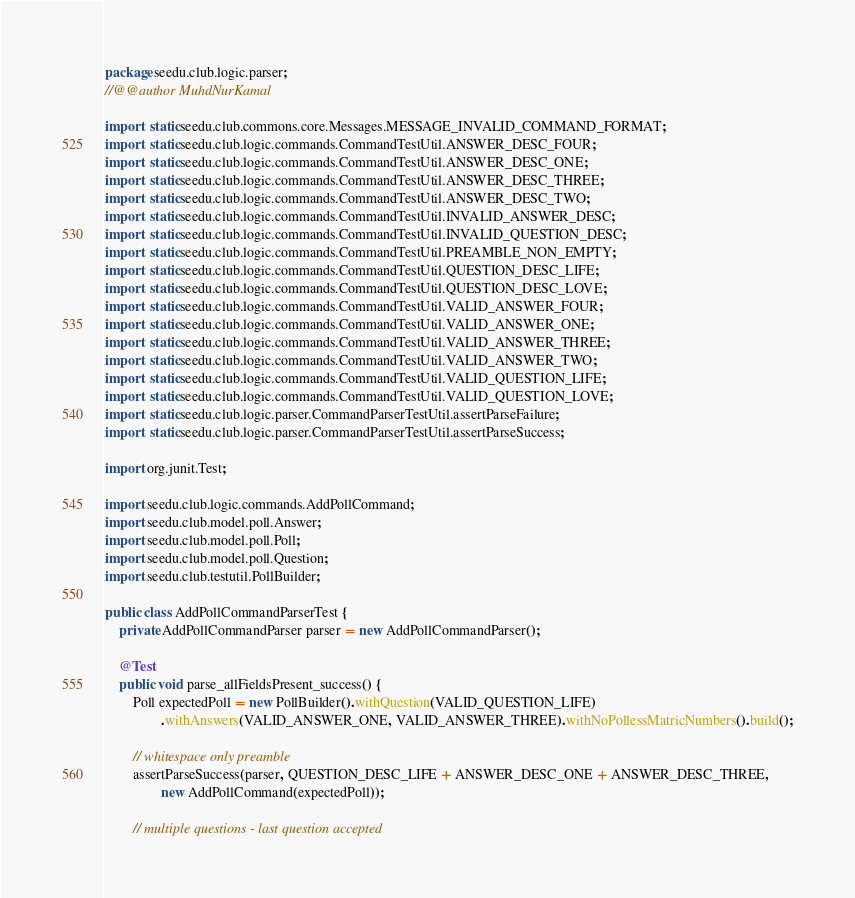Convert code to text. <code><loc_0><loc_0><loc_500><loc_500><_Java_>package seedu.club.logic.parser;
//@@author MuhdNurKamal

import static seedu.club.commons.core.Messages.MESSAGE_INVALID_COMMAND_FORMAT;
import static seedu.club.logic.commands.CommandTestUtil.ANSWER_DESC_FOUR;
import static seedu.club.logic.commands.CommandTestUtil.ANSWER_DESC_ONE;
import static seedu.club.logic.commands.CommandTestUtil.ANSWER_DESC_THREE;
import static seedu.club.logic.commands.CommandTestUtil.ANSWER_DESC_TWO;
import static seedu.club.logic.commands.CommandTestUtil.INVALID_ANSWER_DESC;
import static seedu.club.logic.commands.CommandTestUtil.INVALID_QUESTION_DESC;
import static seedu.club.logic.commands.CommandTestUtil.PREAMBLE_NON_EMPTY;
import static seedu.club.logic.commands.CommandTestUtil.QUESTION_DESC_LIFE;
import static seedu.club.logic.commands.CommandTestUtil.QUESTION_DESC_LOVE;
import static seedu.club.logic.commands.CommandTestUtil.VALID_ANSWER_FOUR;
import static seedu.club.logic.commands.CommandTestUtil.VALID_ANSWER_ONE;
import static seedu.club.logic.commands.CommandTestUtil.VALID_ANSWER_THREE;
import static seedu.club.logic.commands.CommandTestUtil.VALID_ANSWER_TWO;
import static seedu.club.logic.commands.CommandTestUtil.VALID_QUESTION_LIFE;
import static seedu.club.logic.commands.CommandTestUtil.VALID_QUESTION_LOVE;
import static seedu.club.logic.parser.CommandParserTestUtil.assertParseFailure;
import static seedu.club.logic.parser.CommandParserTestUtil.assertParseSuccess;

import org.junit.Test;

import seedu.club.logic.commands.AddPollCommand;
import seedu.club.model.poll.Answer;
import seedu.club.model.poll.Poll;
import seedu.club.model.poll.Question;
import seedu.club.testutil.PollBuilder;

public class AddPollCommandParserTest {
    private AddPollCommandParser parser = new AddPollCommandParser();

    @Test
    public void parse_allFieldsPresent_success() {
        Poll expectedPoll = new PollBuilder().withQuestion(VALID_QUESTION_LIFE)
                .withAnswers(VALID_ANSWER_ONE, VALID_ANSWER_THREE).withNoPollessMatricNumbers().build();

        // whitespace only preamble
        assertParseSuccess(parser, QUESTION_DESC_LIFE + ANSWER_DESC_ONE + ANSWER_DESC_THREE,
                new AddPollCommand(expectedPoll));

        // multiple questions - last question accepted</code> 